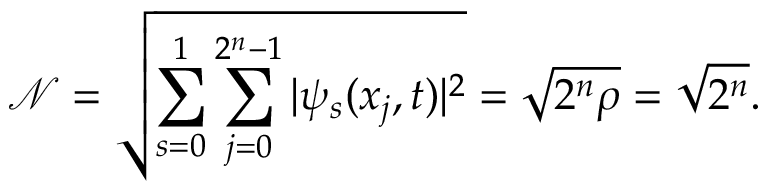<formula> <loc_0><loc_0><loc_500><loc_500>\mathcal { N } = \sqrt { \sum _ { s = 0 } ^ { 1 } \sum _ { j = 0 } ^ { 2 ^ { n } - 1 } | \psi _ { s } ( x _ { j } , t ) | ^ { 2 } } = \sqrt { 2 ^ { n } \rho } = \sqrt { 2 ^ { n } } .</formula> 